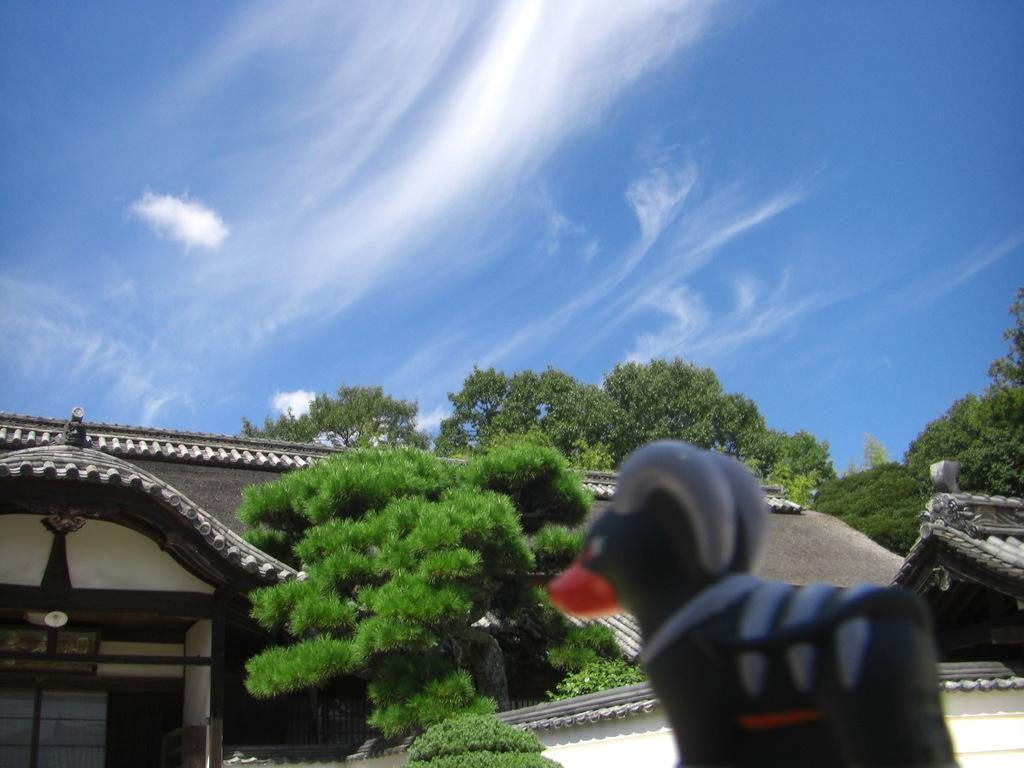What is the color of the sky in the image? The sky is blue in color. What can be seen in the sky in the image? There are clouds visible in the image. What type of structures are present in the image? There are houses in the image. What type of vegetation is present in the image? There are trees in the image. What type of artwork is present in the image? There is a statue in the image. Can you tell me how many balloons are tied to the statue in the image? There are no balloons present in the image; only the statue is visible. What type of slope can be seen in the image? There is no slope present in the image. 